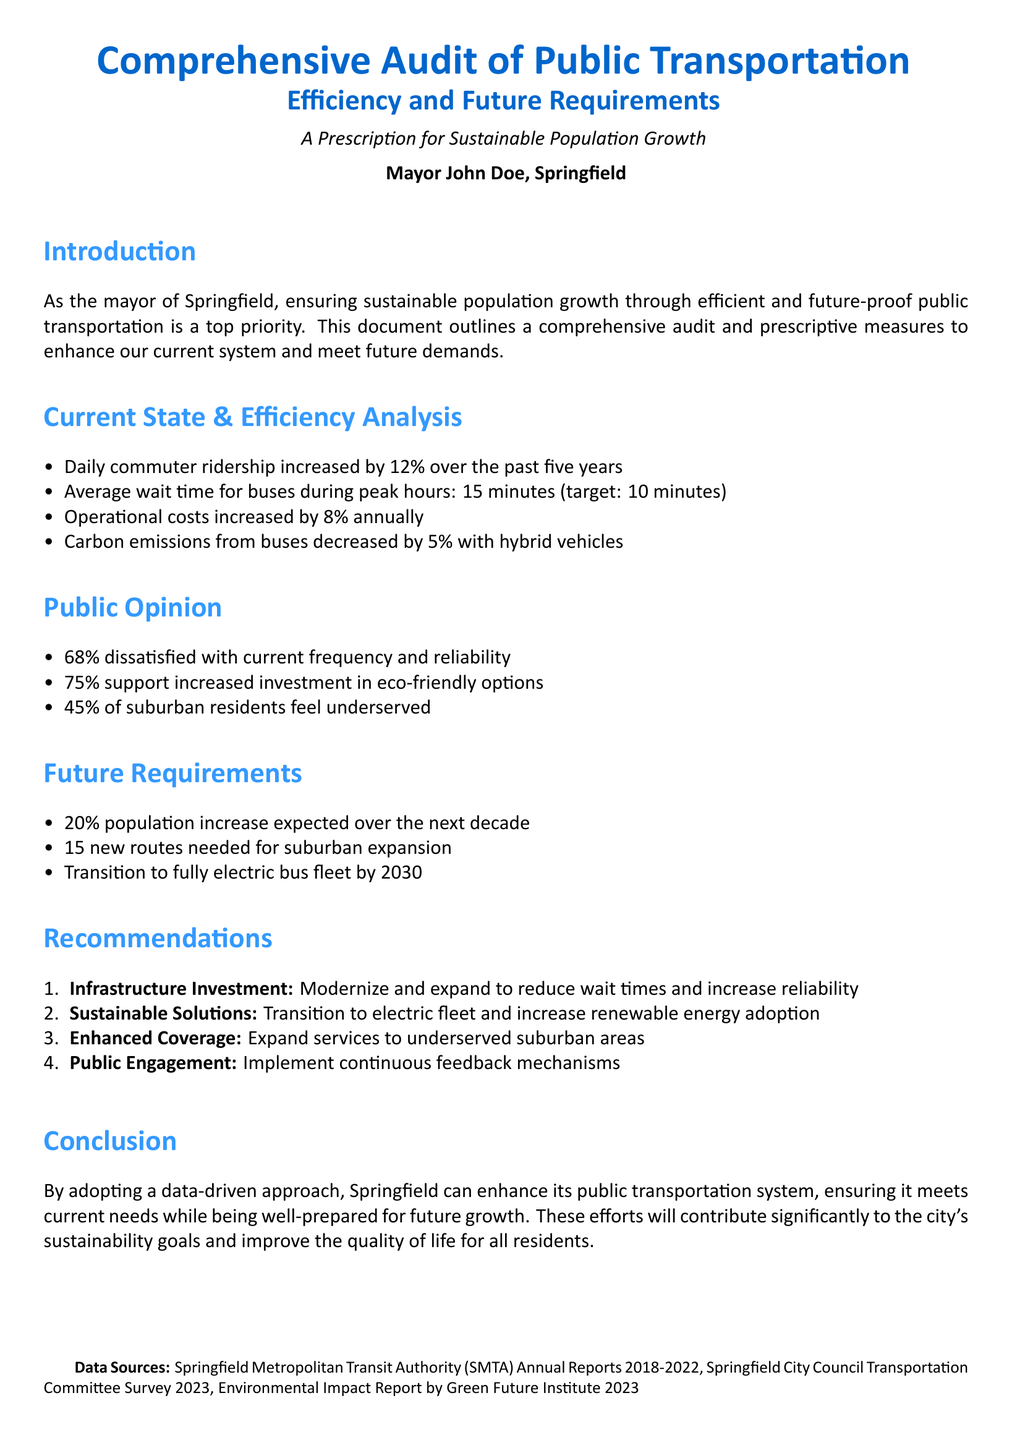What is the increase in daily commuter ridership over the past five years? The daily commuter ridership has increased by 12% over the past five years.
Answer: 12% What is the average wait time for buses during peak hours? The average wait time for buses during peak hours is 15 minutes.
Answer: 15 minutes What percentage of residents support increased investment in eco-friendly options? 75% of residents support increased investment in eco-friendly options.
Answer: 75% How many new routes are needed for suburban expansion? The document states that 15 new routes are needed for suburban expansion.
Answer: 15 What is the target average wait time for buses? The target average wait time for buses is 10 minutes.
Answer: 10 minutes What is the expected population increase over the next decade? A 20% population increase is expected over the next decade.
Answer: 20% What type of fleet transition is planned by 2030? The city plans to transition to a fully electric bus fleet by 2030.
Answer: fully electric What is the annual increase in operational costs? Operational costs have increased by 8% annually.
Answer: 8% What is the satisfaction level of residents regarding current frequency and reliability? 68% of residents are dissatisfied with current frequency and reliability.
Answer: 68% What are the recommendations aimed at? The recommendations aim to enhance public transportation.
Answer: enhance public transportation 